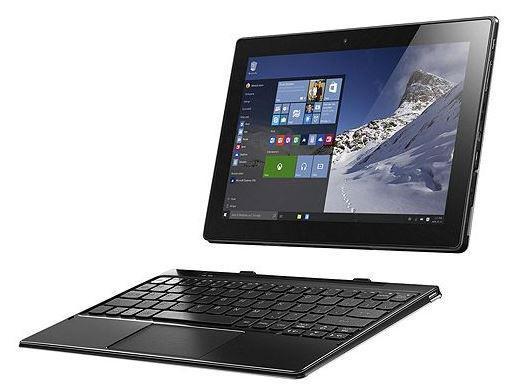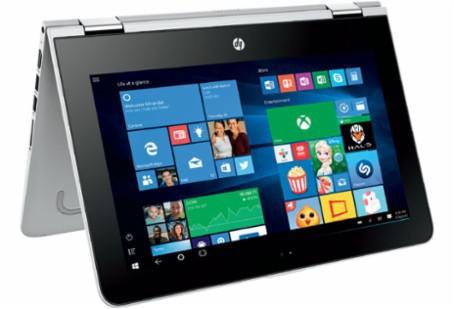The first image is the image on the left, the second image is the image on the right. Considering the images on both sides, is "There is one computer in each image." valid? Answer yes or no. Yes. The first image is the image on the left, the second image is the image on the right. Given the left and right images, does the statement "The left and right image contains the same number of two in one laptops." hold true? Answer yes or no. Yes. 